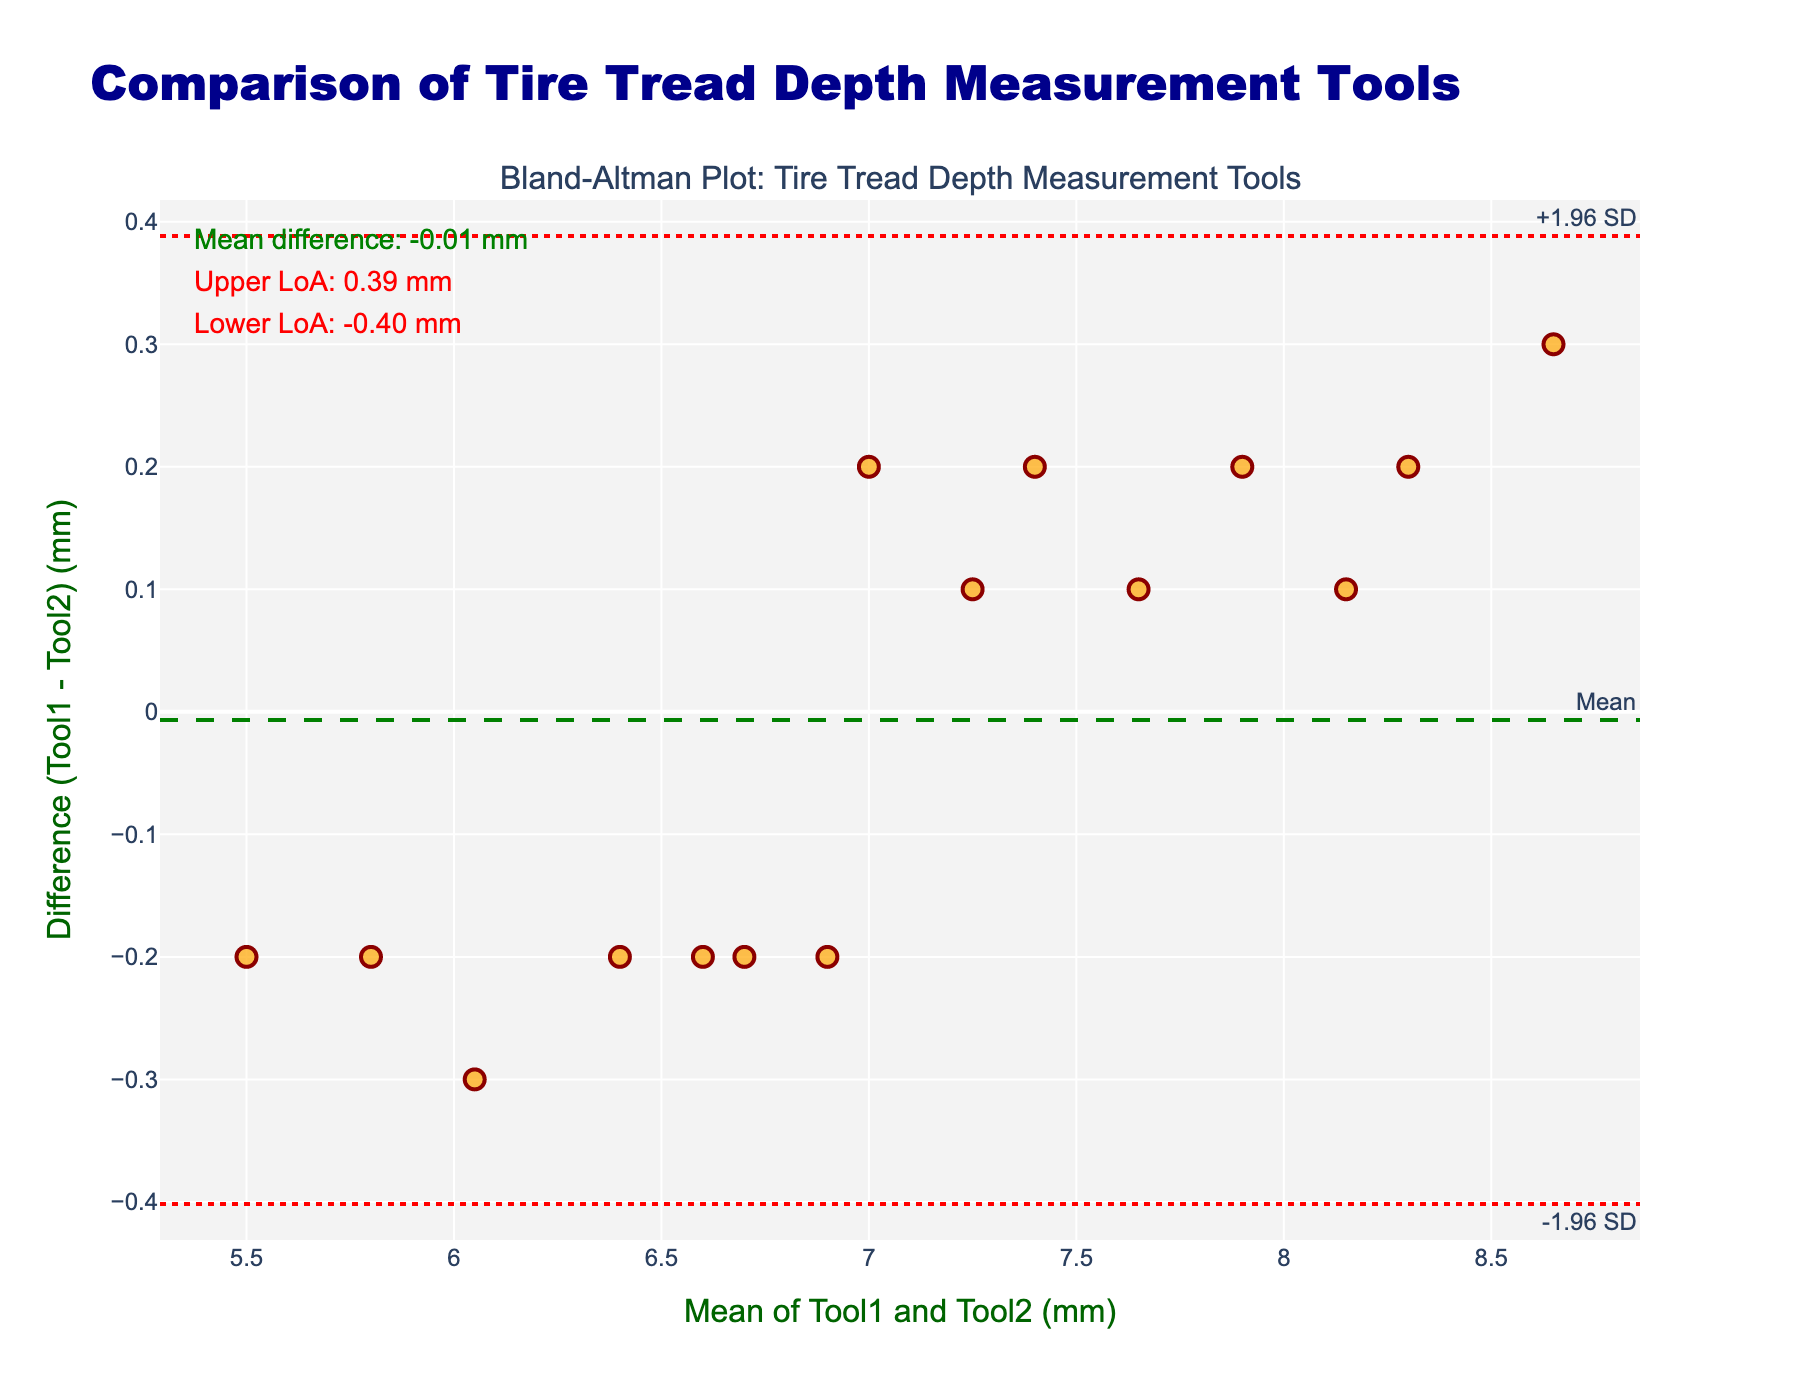How many data points are there in the plot? Count the number of markers in the scatter plot to determine the number of data points.
Answer: 15 What is the title of the plot? Read the title text displayed at the top of the plot.
Answer: Comparison of Tire Tread Depth Measurement Tools What is the mean difference between the two measurement tools? Locate the green dashed line labeled "Mean" and read the corresponding value annotated near it.
Answer: 0.03 mm What does the y-axis represent? Examine the y-axis label text which describes what the y-axis measures.
Answer: Difference (Tool1 - Tool2) (mm) What is the upper limit of agreement (LoA)? Find the upper red dotted line labeled "+1.96 SD" and read the annotated value next to it.
Answer: 0.36 mm What is the lower limit of agreement (LoA)? Find the lower red dotted line labeled "-1.96 SD" and read the annotated value next to it.
Answer: -0.30 mm Which tire measurement tool tends to give higher readings on average? Observe the distribution of differences in the plot. If the majority of the points are below the mean difference line, it indicates that Tool2 tends to give higher readings.
Answer: Tool2 What is the range of the mean values of Tool1 and Tool2? Observe the x-axis range which represents the mean values of the two tools. Note the smallest and largest values on the x-axis.
Answer: Approx. 5.5 mm to 8.5 mm How do most differences between Tool1 and Tool2 compare to the mean difference? Examine the distribution of markers relative to the mean difference line (green dashed line). Notice how many points fall above or below this line.
Answer: Most points are close to the mean difference line In which range do most of the difference values fall? Observe the y-axis range and see where the majority of the markers are concentrated along this axis.
Answer: Between -0.2 mm and 0.2 mm 